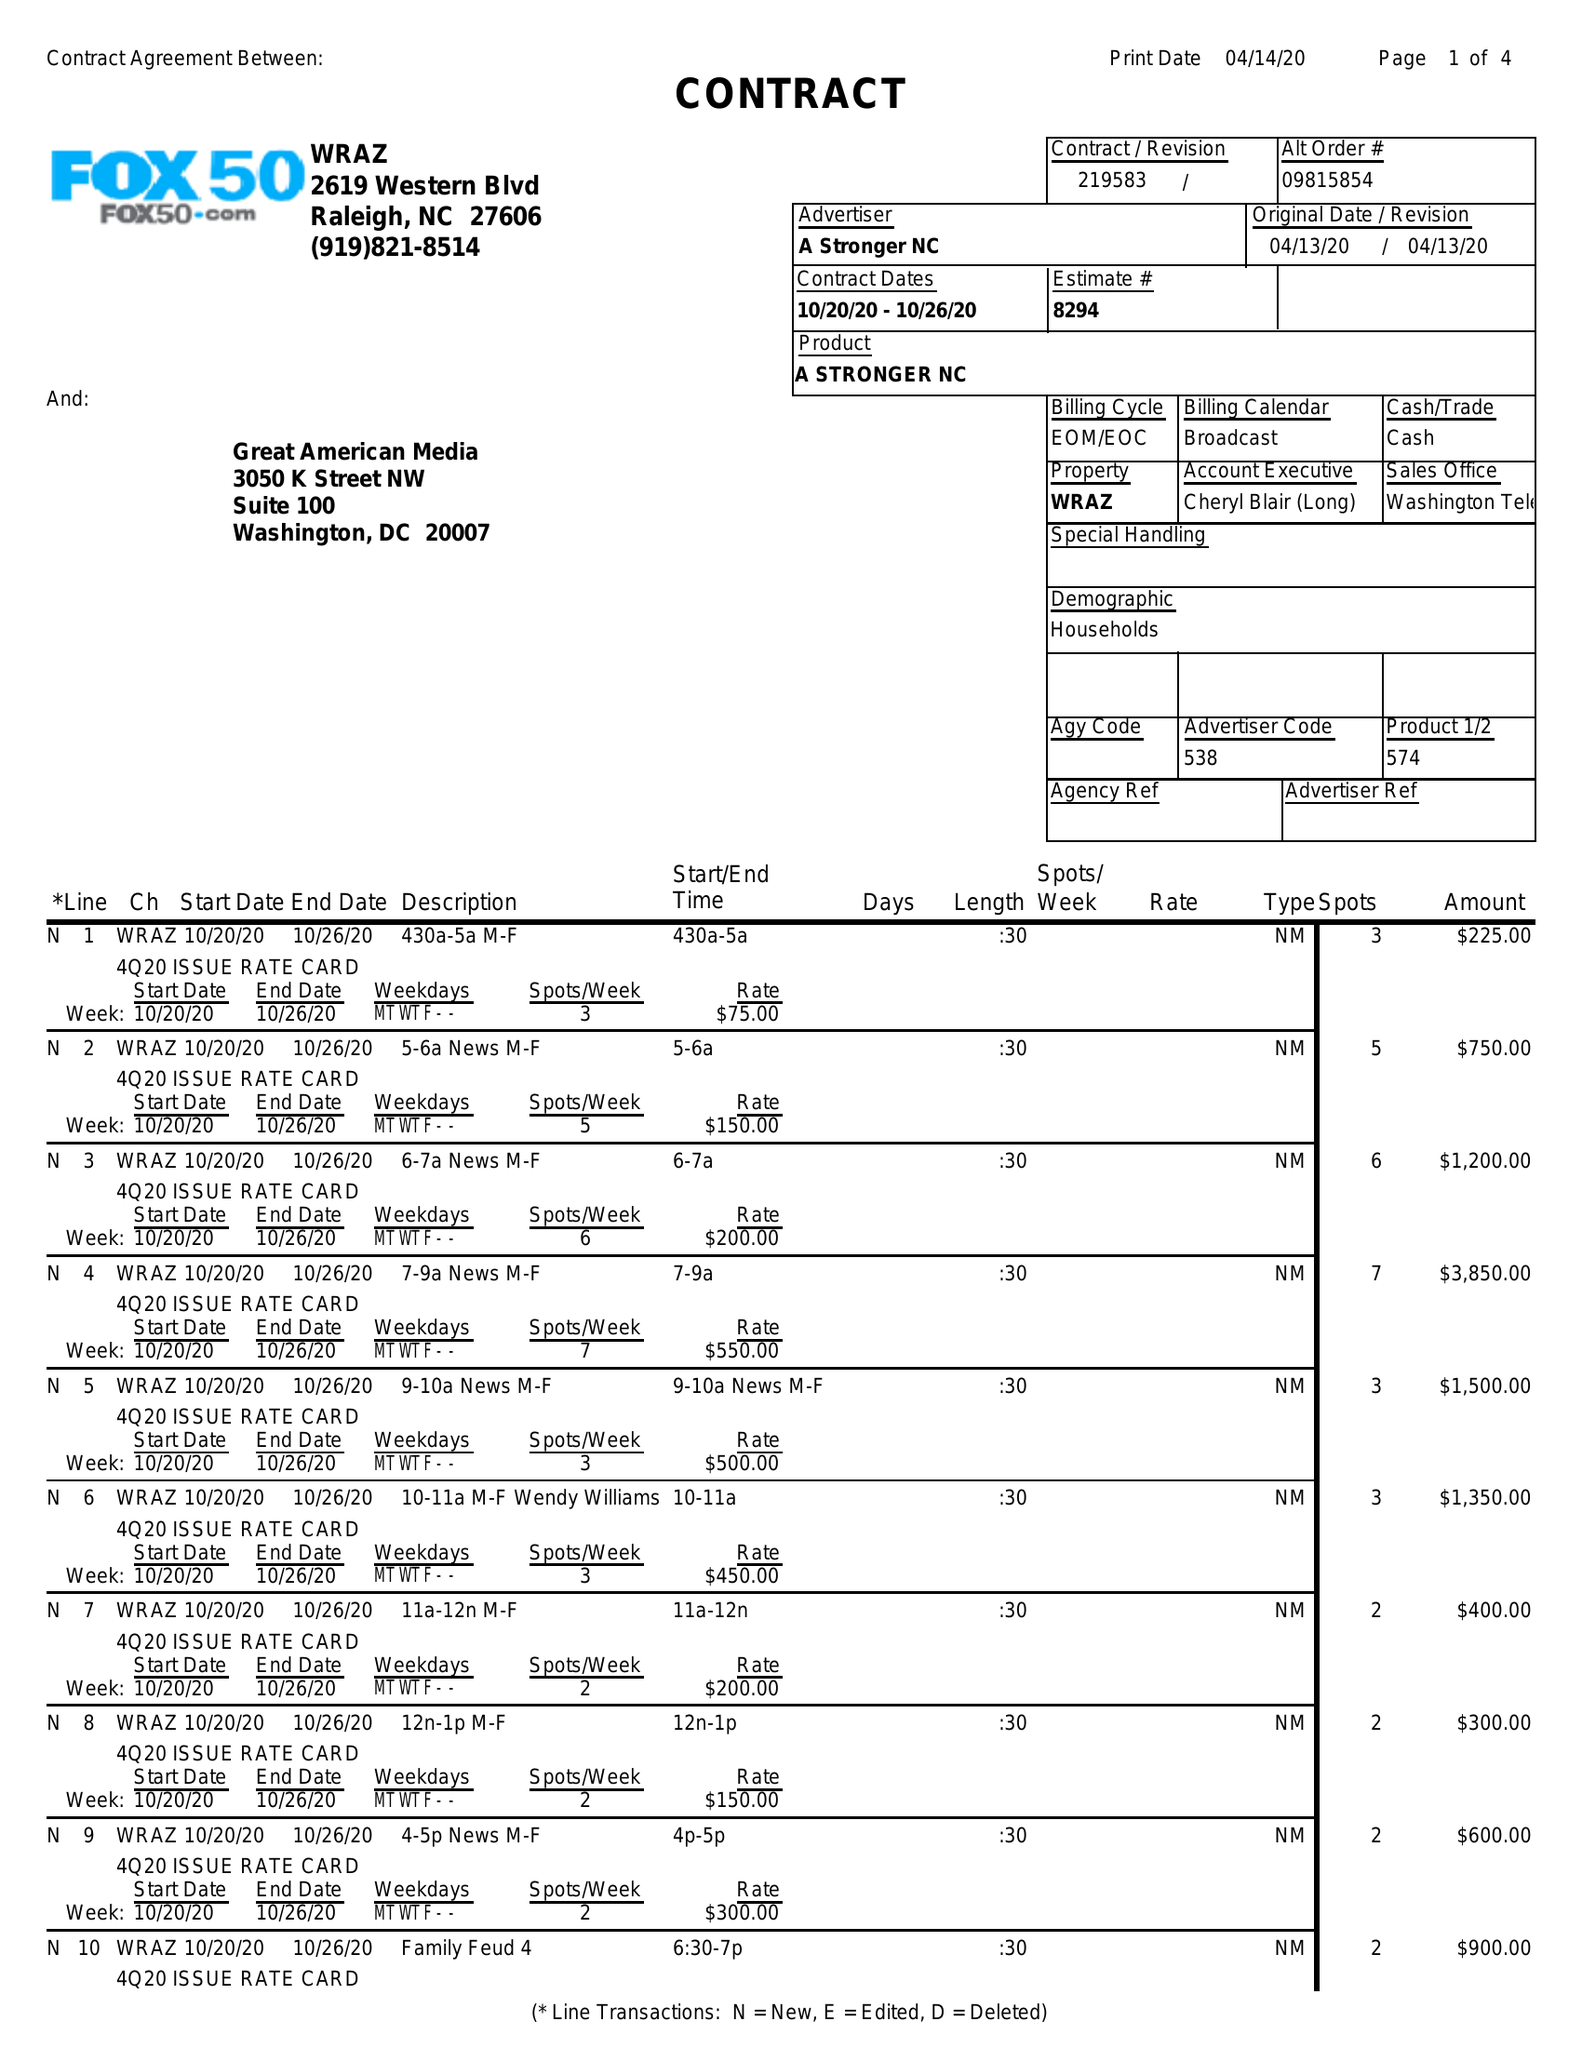What is the value for the flight_to?
Answer the question using a single word or phrase. 10/26/20 